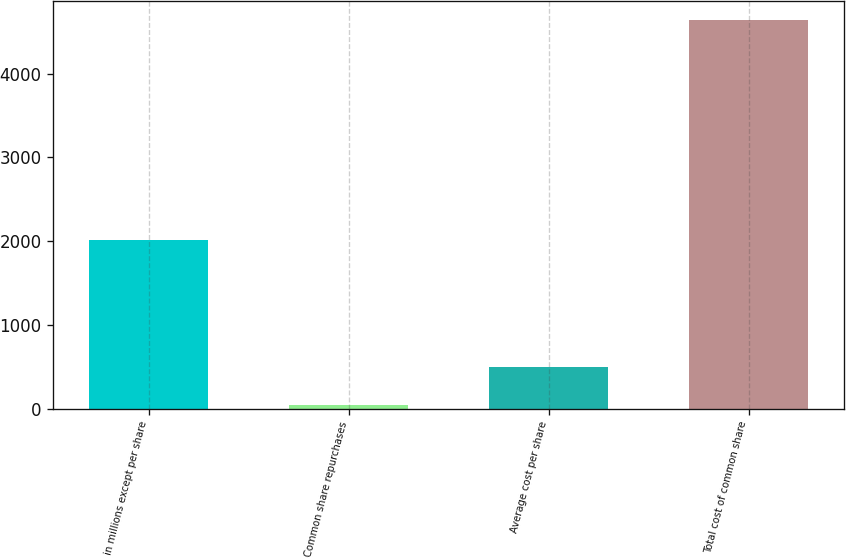Convert chart to OTSL. <chart><loc_0><loc_0><loc_500><loc_500><bar_chart><fcel>in millions except per share<fcel>Common share repurchases<fcel>Average cost per share<fcel>Total cost of common share<nl><fcel>2012<fcel>42<fcel>501.5<fcel>4637<nl></chart> 